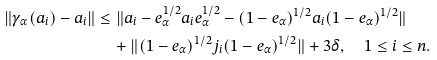<formula> <loc_0><loc_0><loc_500><loc_500>\| \gamma _ { \alpha } ( a _ { i } ) - a _ { i } \| & \leq \| a _ { i } - e ^ { 1 / 2 } _ { \alpha } a _ { i } e ^ { 1 / 2 } _ { \alpha } - ( 1 - e _ { \alpha } ) ^ { 1 / 2 } a _ { i } ( 1 - e _ { \alpha } ) ^ { 1 / 2 } \| \\ & \quad + \| ( 1 - e _ { \alpha } ) ^ { 1 / 2 } j _ { i } ( 1 - e _ { \alpha } ) ^ { 1 / 2 } \| + 3 \delta , \quad 1 \leq i \leq n .</formula> 